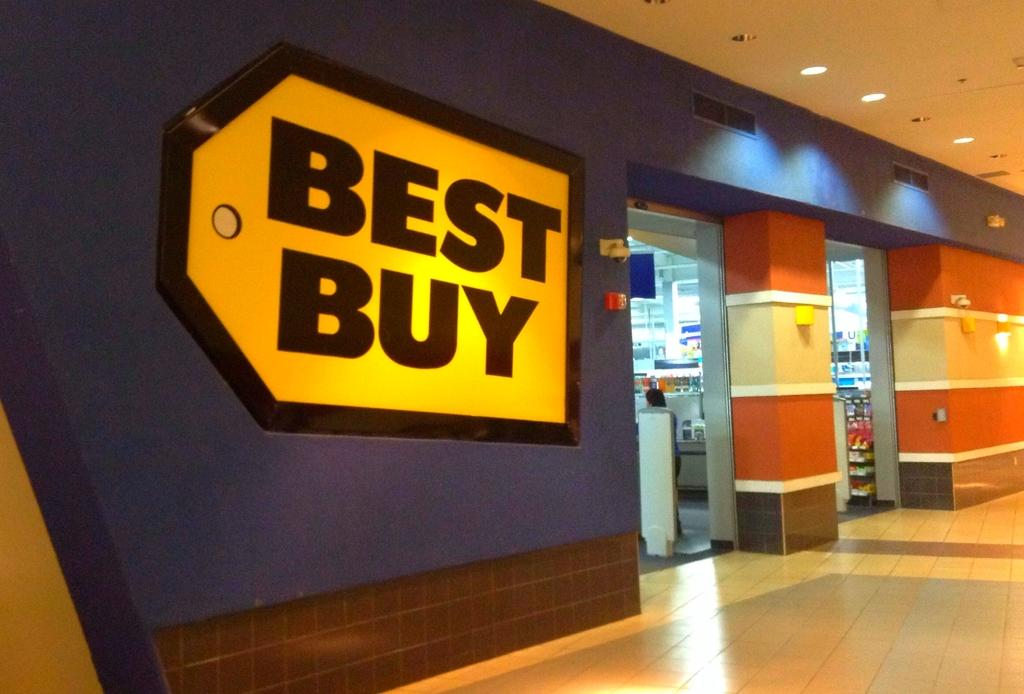<image>
Present a compact description of the photo's key features. the outside shopping entrance to a best buy store 